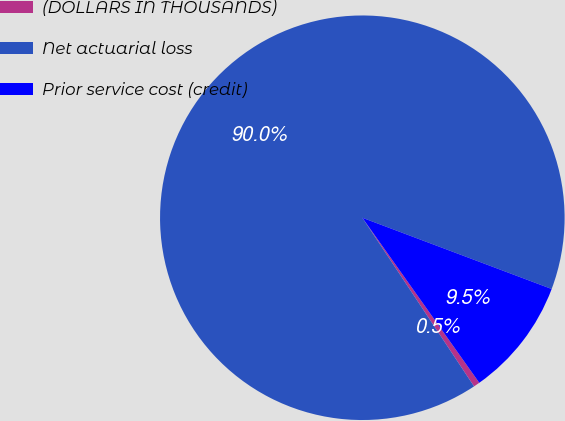<chart> <loc_0><loc_0><loc_500><loc_500><pie_chart><fcel>(DOLLARS IN THOUSANDS)<fcel>Net actuarial loss<fcel>Prior service cost (credit)<nl><fcel>0.5%<fcel>90.04%<fcel>9.46%<nl></chart> 